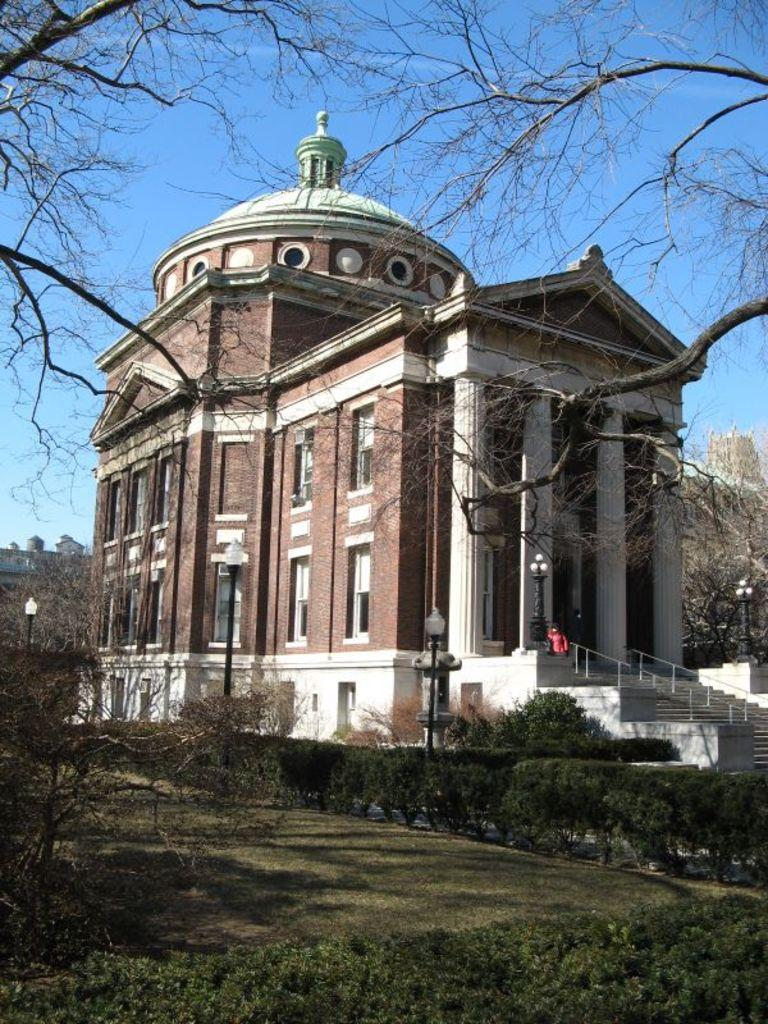What is the main subject of the image? There is a building at the center of the image. What can be seen in front of the building? There are many trees and plants in front of the building. What is visible in the background of the image? The sky is visible in the background of the image. What type of underwear is hanging on the trees in the image? There is no underwear present in the image; it features a building with trees and plants in front of it. What material is the copper used for in the image? There is no copper mentioned or depicted in the image. 